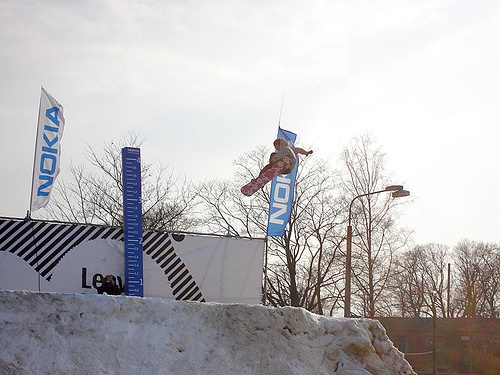Describe the objects in this image and their specific colors. I can see snowboard in lightgray, brown, gray, and maroon tones, people in lightgray, gray, and maroon tones, and people in lightgray, black, and gray tones in this image. 